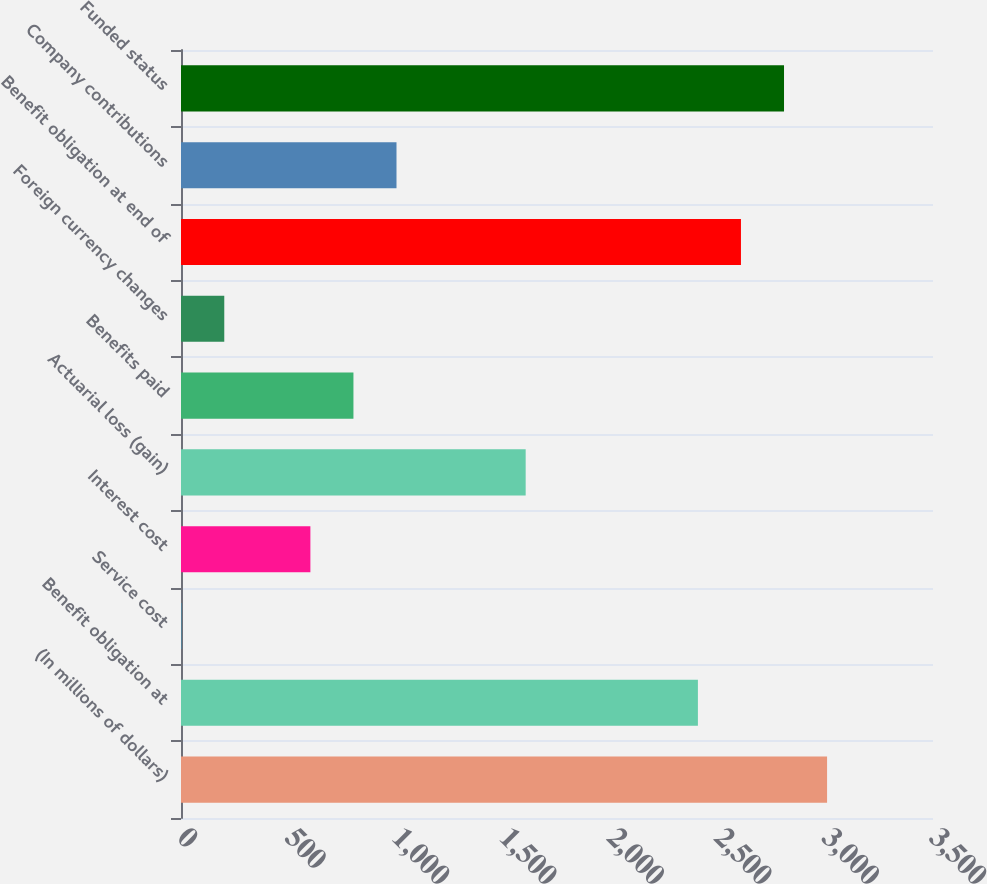Convert chart. <chart><loc_0><loc_0><loc_500><loc_500><bar_chart><fcel>(In millions of dollars)<fcel>Benefit obligation at<fcel>Service cost<fcel>Interest cost<fcel>Actuarial loss (gain)<fcel>Benefits paid<fcel>Foreign currency changes<fcel>Benefit obligation at end of<fcel>Company contributions<fcel>Funded status<nl><fcel>3007<fcel>2405.8<fcel>1<fcel>602.2<fcel>1604.2<fcel>802.6<fcel>201.4<fcel>2606.2<fcel>1003<fcel>2806.6<nl></chart> 